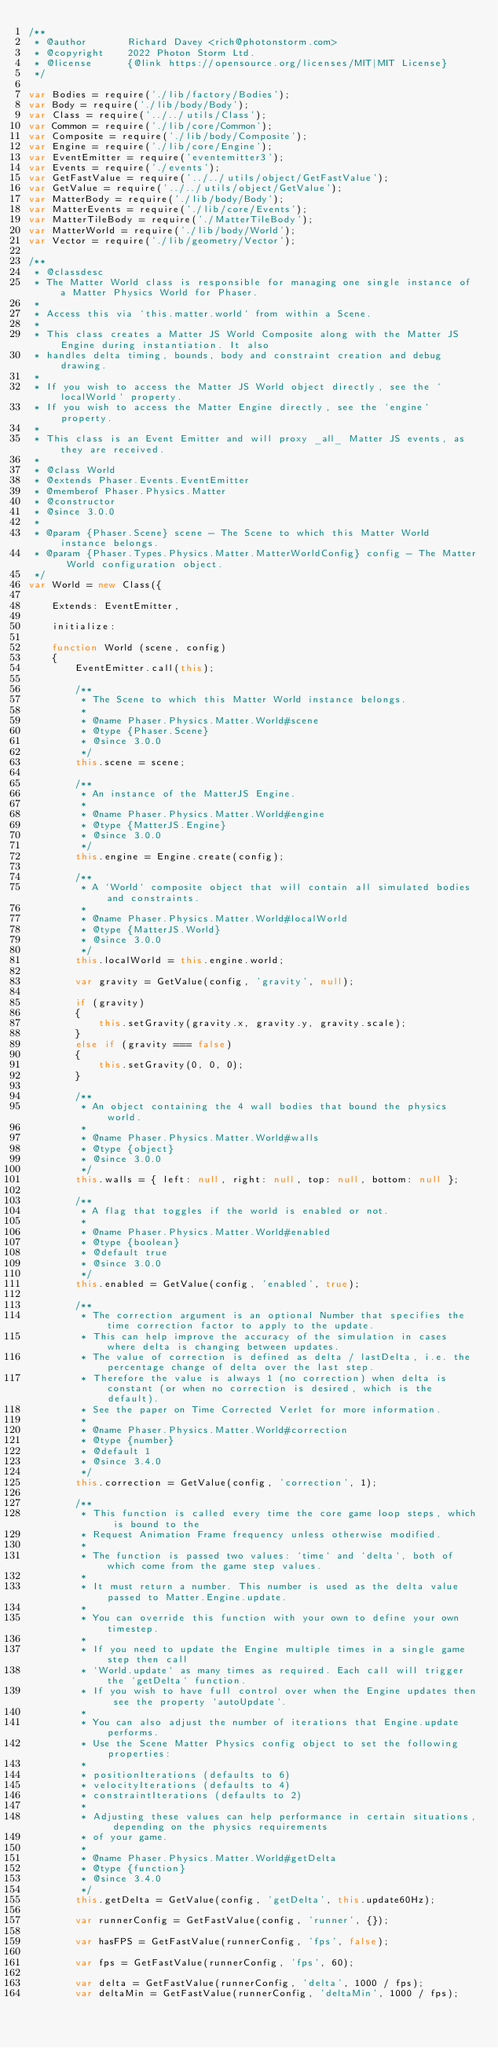<code> <loc_0><loc_0><loc_500><loc_500><_JavaScript_>/**
 * @author       Richard Davey <rich@photonstorm.com>
 * @copyright    2022 Photon Storm Ltd.
 * @license      {@link https://opensource.org/licenses/MIT|MIT License}
 */

var Bodies = require('./lib/factory/Bodies');
var Body = require('./lib/body/Body');
var Class = require('../../utils/Class');
var Common = require('./lib/core/Common');
var Composite = require('./lib/body/Composite');
var Engine = require('./lib/core/Engine');
var EventEmitter = require('eventemitter3');
var Events = require('./events');
var GetFastValue = require('../../utils/object/GetFastValue');
var GetValue = require('../../utils/object/GetValue');
var MatterBody = require('./lib/body/Body');
var MatterEvents = require('./lib/core/Events');
var MatterTileBody = require('./MatterTileBody');
var MatterWorld = require('./lib/body/World');
var Vector = require('./lib/geometry/Vector');

/**
 * @classdesc
 * The Matter World class is responsible for managing one single instance of a Matter Physics World for Phaser.
 *
 * Access this via `this.matter.world` from within a Scene.
 *
 * This class creates a Matter JS World Composite along with the Matter JS Engine during instantiation. It also
 * handles delta timing, bounds, body and constraint creation and debug drawing.
 *
 * If you wish to access the Matter JS World object directly, see the `localWorld` property.
 * If you wish to access the Matter Engine directly, see the `engine` property.
 *
 * This class is an Event Emitter and will proxy _all_ Matter JS events, as they are received.
 *
 * @class World
 * @extends Phaser.Events.EventEmitter
 * @memberof Phaser.Physics.Matter
 * @constructor
 * @since 3.0.0
 *
 * @param {Phaser.Scene} scene - The Scene to which this Matter World instance belongs.
 * @param {Phaser.Types.Physics.Matter.MatterWorldConfig} config - The Matter World configuration object.
 */
var World = new Class({

    Extends: EventEmitter,

    initialize:

    function World (scene, config)
    {
        EventEmitter.call(this);

        /**
         * The Scene to which this Matter World instance belongs.
         *
         * @name Phaser.Physics.Matter.World#scene
         * @type {Phaser.Scene}
         * @since 3.0.0
         */
        this.scene = scene;

        /**
         * An instance of the MatterJS Engine.
         *
         * @name Phaser.Physics.Matter.World#engine
         * @type {MatterJS.Engine}
         * @since 3.0.0
         */
        this.engine = Engine.create(config);

        /**
         * A `World` composite object that will contain all simulated bodies and constraints.
         *
         * @name Phaser.Physics.Matter.World#localWorld
         * @type {MatterJS.World}
         * @since 3.0.0
         */
        this.localWorld = this.engine.world;

        var gravity = GetValue(config, 'gravity', null);

        if (gravity)
        {
            this.setGravity(gravity.x, gravity.y, gravity.scale);
        }
        else if (gravity === false)
        {
            this.setGravity(0, 0, 0);
        }

        /**
         * An object containing the 4 wall bodies that bound the physics world.
         *
         * @name Phaser.Physics.Matter.World#walls
         * @type {object}
         * @since 3.0.0
         */
        this.walls = { left: null, right: null, top: null, bottom: null };

        /**
         * A flag that toggles if the world is enabled or not.
         *
         * @name Phaser.Physics.Matter.World#enabled
         * @type {boolean}
         * @default true
         * @since 3.0.0
         */
        this.enabled = GetValue(config, 'enabled', true);

        /**
         * The correction argument is an optional Number that specifies the time correction factor to apply to the update.
         * This can help improve the accuracy of the simulation in cases where delta is changing between updates.
         * The value of correction is defined as delta / lastDelta, i.e. the percentage change of delta over the last step.
         * Therefore the value is always 1 (no correction) when delta is constant (or when no correction is desired, which is the default).
         * See the paper on Time Corrected Verlet for more information.
         *
         * @name Phaser.Physics.Matter.World#correction
         * @type {number}
         * @default 1
         * @since 3.4.0
         */
        this.correction = GetValue(config, 'correction', 1);

        /**
         * This function is called every time the core game loop steps, which is bound to the
         * Request Animation Frame frequency unless otherwise modified.
         *
         * The function is passed two values: `time` and `delta`, both of which come from the game step values.
         *
         * It must return a number. This number is used as the delta value passed to Matter.Engine.update.
         *
         * You can override this function with your own to define your own timestep.
         *
         * If you need to update the Engine multiple times in a single game step then call
         * `World.update` as many times as required. Each call will trigger the `getDelta` function.
         * If you wish to have full control over when the Engine updates then see the property `autoUpdate`.
         *
         * You can also adjust the number of iterations that Engine.update performs.
         * Use the Scene Matter Physics config object to set the following properties:
         *
         * positionIterations (defaults to 6)
         * velocityIterations (defaults to 4)
         * constraintIterations (defaults to 2)
         *
         * Adjusting these values can help performance in certain situations, depending on the physics requirements
         * of your game.
         *
         * @name Phaser.Physics.Matter.World#getDelta
         * @type {function}
         * @since 3.4.0
         */
        this.getDelta = GetValue(config, 'getDelta', this.update60Hz);

        var runnerConfig = GetFastValue(config, 'runner', {});

        var hasFPS = GetFastValue(runnerConfig, 'fps', false);

        var fps = GetFastValue(runnerConfig, 'fps', 60);

        var delta = GetFastValue(runnerConfig, 'delta', 1000 / fps);
        var deltaMin = GetFastValue(runnerConfig, 'deltaMin', 1000 / fps);</code> 